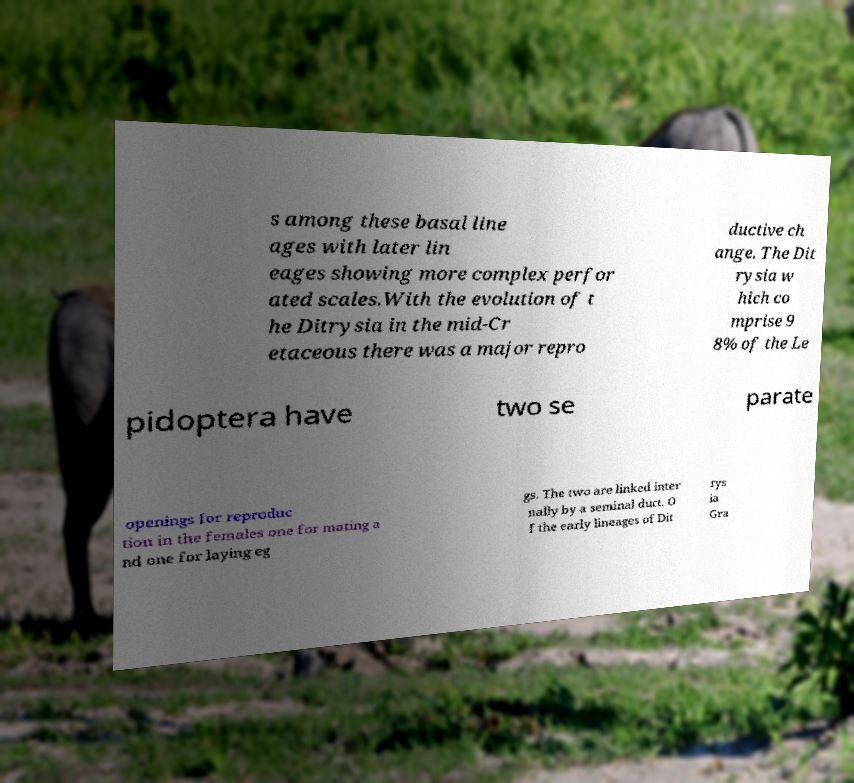Can you accurately transcribe the text from the provided image for me? s among these basal line ages with later lin eages showing more complex perfor ated scales.With the evolution of t he Ditrysia in the mid-Cr etaceous there was a major repro ductive ch ange. The Dit rysia w hich co mprise 9 8% of the Le pidoptera have two se parate openings for reproduc tion in the females one for mating a nd one for laying eg gs. The two are linked inter nally by a seminal duct. O f the early lineages of Dit rys ia Gra 